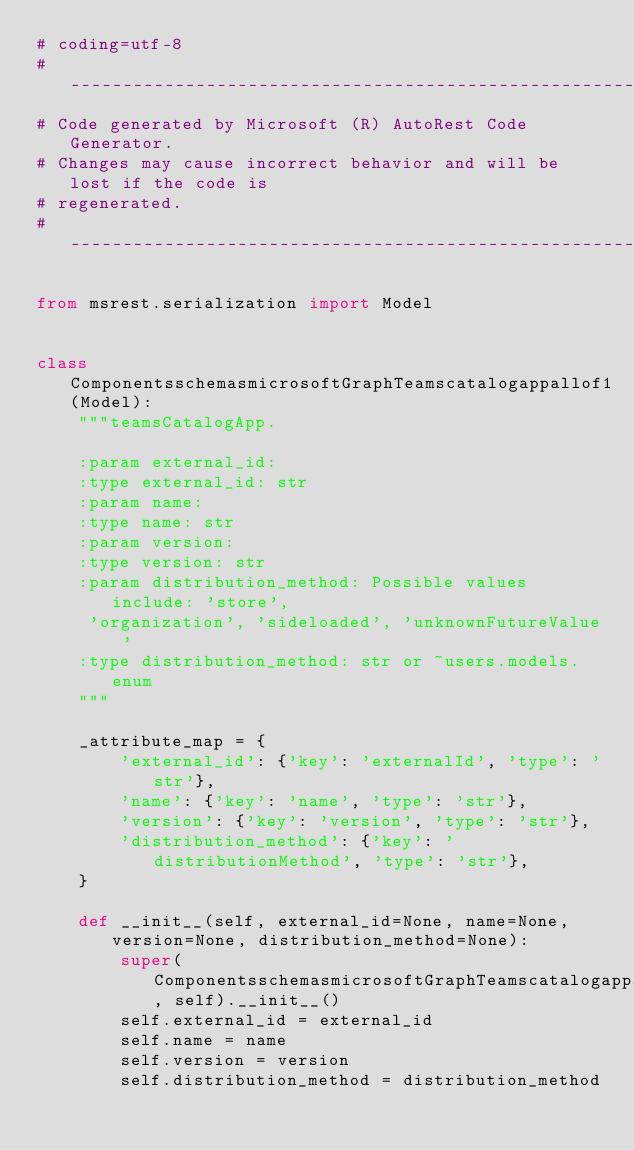Convert code to text. <code><loc_0><loc_0><loc_500><loc_500><_Python_># coding=utf-8
# --------------------------------------------------------------------------
# Code generated by Microsoft (R) AutoRest Code Generator.
# Changes may cause incorrect behavior and will be lost if the code is
# regenerated.
# --------------------------------------------------------------------------

from msrest.serialization import Model


class ComponentsschemasmicrosoftGraphTeamscatalogappallof1(Model):
    """teamsCatalogApp.

    :param external_id:
    :type external_id: str
    :param name:
    :type name: str
    :param version:
    :type version: str
    :param distribution_method: Possible values include: 'store',
     'organization', 'sideloaded', 'unknownFutureValue'
    :type distribution_method: str or ~users.models.enum
    """

    _attribute_map = {
        'external_id': {'key': 'externalId', 'type': 'str'},
        'name': {'key': 'name', 'type': 'str'},
        'version': {'key': 'version', 'type': 'str'},
        'distribution_method': {'key': 'distributionMethod', 'type': 'str'},
    }

    def __init__(self, external_id=None, name=None, version=None, distribution_method=None):
        super(ComponentsschemasmicrosoftGraphTeamscatalogappallof1, self).__init__()
        self.external_id = external_id
        self.name = name
        self.version = version
        self.distribution_method = distribution_method
</code> 